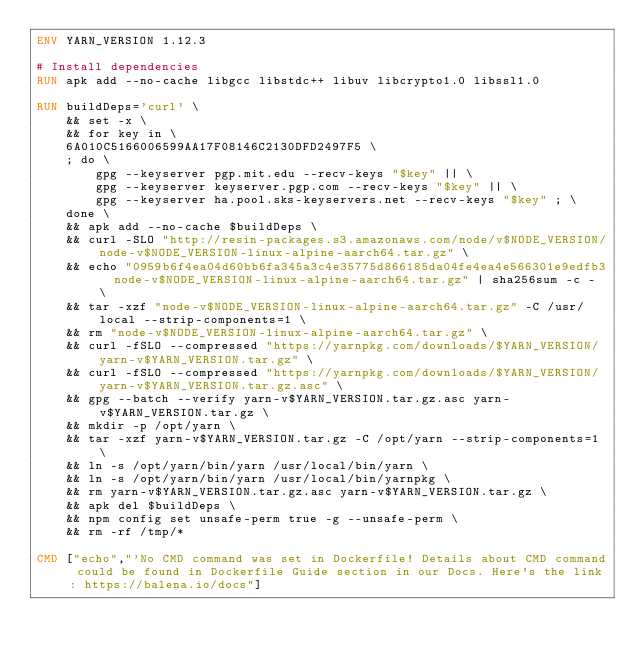<code> <loc_0><loc_0><loc_500><loc_500><_Dockerfile_>ENV YARN_VERSION 1.12.3

# Install dependencies
RUN apk add --no-cache libgcc libstdc++ libuv libcrypto1.0 libssl1.0

RUN buildDeps='curl' \
	&& set -x \
	&& for key in \
	6A010C5166006599AA17F08146C2130DFD2497F5 \
	; do \
		gpg --keyserver pgp.mit.edu --recv-keys "$key" || \
		gpg --keyserver keyserver.pgp.com --recv-keys "$key" || \
		gpg --keyserver ha.pool.sks-keyservers.net --recv-keys "$key" ; \
	done \
	&& apk add --no-cache $buildDeps \
	&& curl -SLO "http://resin-packages.s3.amazonaws.com/node/v$NODE_VERSION/node-v$NODE_VERSION-linux-alpine-aarch64.tar.gz" \
	&& echo "0959b6f4ea04d60bb6fa345a3c4e35775d866185da04fe4ea4e566301e9edfb3  node-v$NODE_VERSION-linux-alpine-aarch64.tar.gz" | sha256sum -c - \
	&& tar -xzf "node-v$NODE_VERSION-linux-alpine-aarch64.tar.gz" -C /usr/local --strip-components=1 \
	&& rm "node-v$NODE_VERSION-linux-alpine-aarch64.tar.gz" \
	&& curl -fSLO --compressed "https://yarnpkg.com/downloads/$YARN_VERSION/yarn-v$YARN_VERSION.tar.gz" \
	&& curl -fSLO --compressed "https://yarnpkg.com/downloads/$YARN_VERSION/yarn-v$YARN_VERSION.tar.gz.asc" \
	&& gpg --batch --verify yarn-v$YARN_VERSION.tar.gz.asc yarn-v$YARN_VERSION.tar.gz \
	&& mkdir -p /opt/yarn \
	&& tar -xzf yarn-v$YARN_VERSION.tar.gz -C /opt/yarn --strip-components=1 \
	&& ln -s /opt/yarn/bin/yarn /usr/local/bin/yarn \
	&& ln -s /opt/yarn/bin/yarn /usr/local/bin/yarnpkg \
	&& rm yarn-v$YARN_VERSION.tar.gz.asc yarn-v$YARN_VERSION.tar.gz \
	&& apk del $buildDeps \
	&& npm config set unsafe-perm true -g --unsafe-perm \
	&& rm -rf /tmp/*

CMD ["echo","'No CMD command was set in Dockerfile! Details about CMD command could be found in Dockerfile Guide section in our Docs. Here's the link: https://balena.io/docs"]</code> 